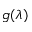<formula> <loc_0><loc_0><loc_500><loc_500>g ( \lambda )</formula> 